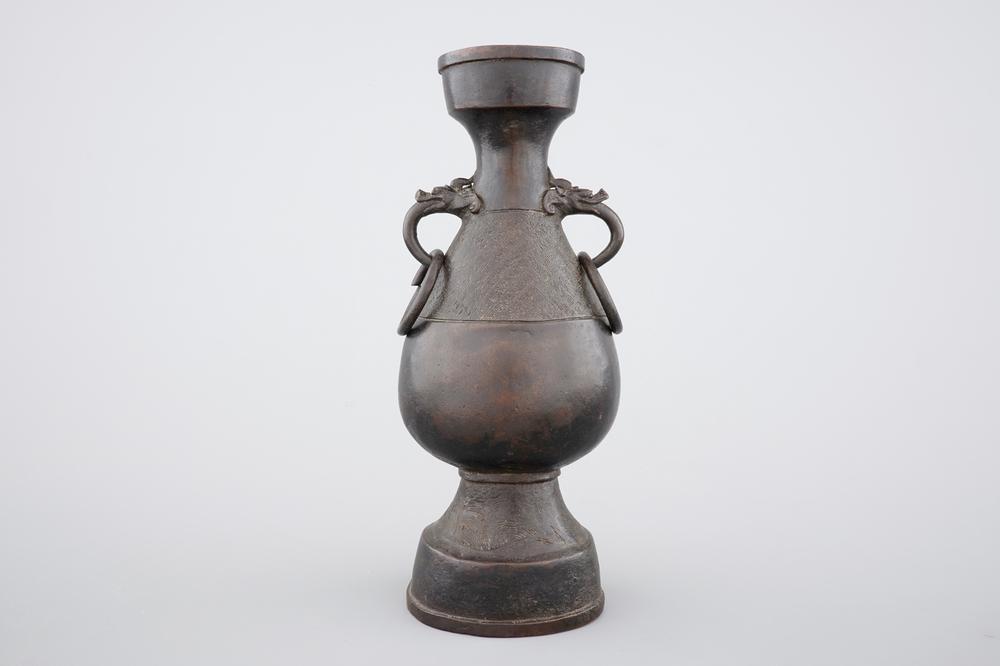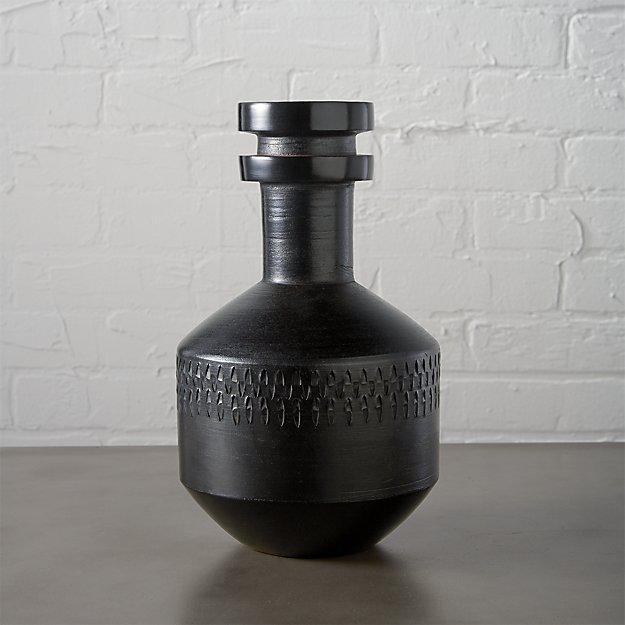The first image is the image on the left, the second image is the image on the right. Examine the images to the left and right. Is the description "the hole in the top of the vase is visible" accurate? Answer yes or no. No. 